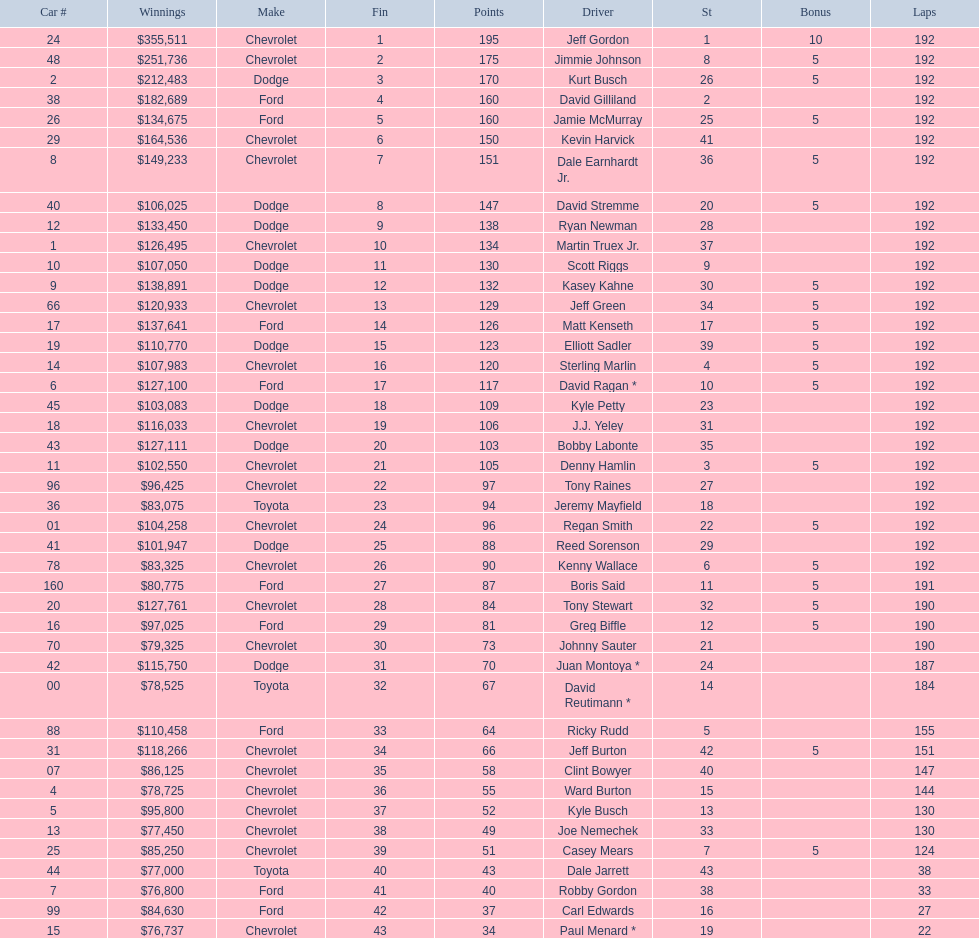How many race car drivers out of the 43 listed drove toyotas? 3. 